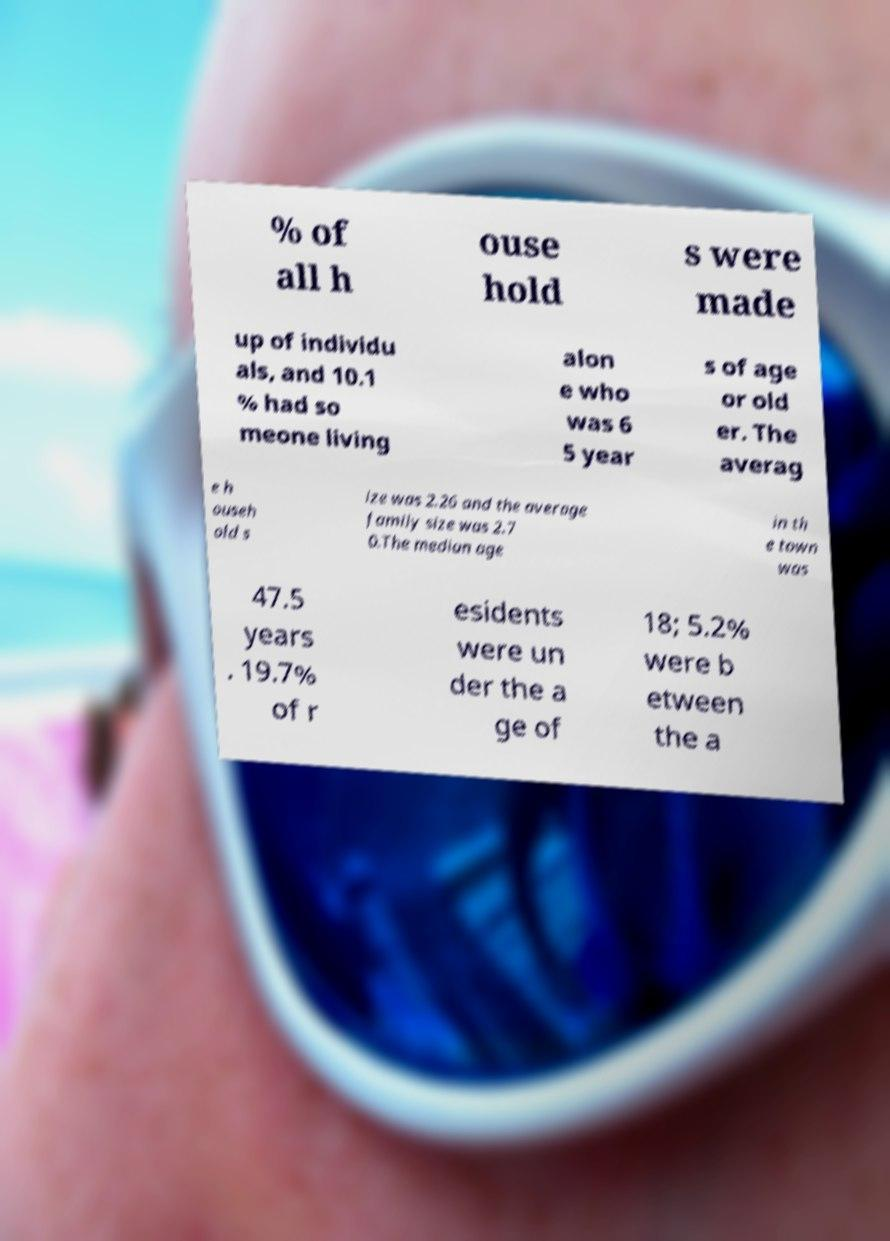Can you read and provide the text displayed in the image?This photo seems to have some interesting text. Can you extract and type it out for me? % of all h ouse hold s were made up of individu als, and 10.1 % had so meone living alon e who was 6 5 year s of age or old er. The averag e h ouseh old s ize was 2.26 and the average family size was 2.7 0.The median age in th e town was 47.5 years . 19.7% of r esidents were un der the a ge of 18; 5.2% were b etween the a 